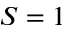Convert formula to latex. <formula><loc_0><loc_0><loc_500><loc_500>S = 1</formula> 